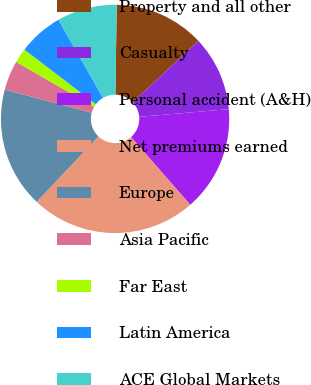Convert chart to OTSL. <chart><loc_0><loc_0><loc_500><loc_500><pie_chart><fcel>Property and all other<fcel>Casualty<fcel>Personal accident (A&H)<fcel>Net premiums earned<fcel>Europe<fcel>Asia Pacific<fcel>Far East<fcel>Latin America<fcel>ACE Global Markets<nl><fcel>12.78%<fcel>10.63%<fcel>14.92%<fcel>23.5%<fcel>17.07%<fcel>4.2%<fcel>2.06%<fcel>6.35%<fcel>8.49%<nl></chart> 